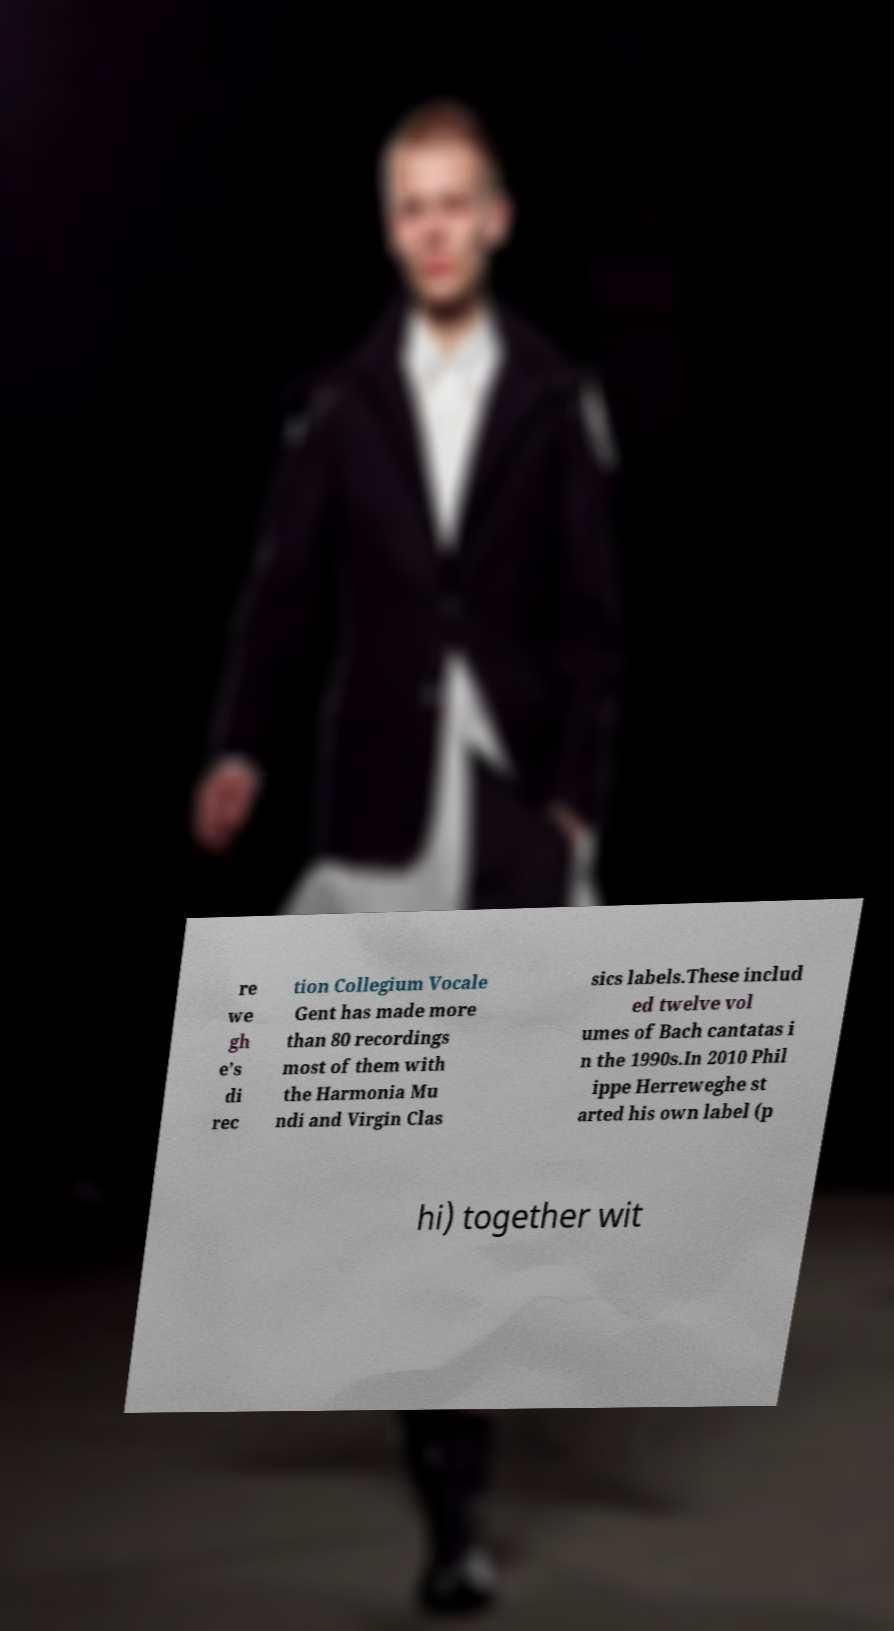There's text embedded in this image that I need extracted. Can you transcribe it verbatim? re we gh e’s di rec tion Collegium Vocale Gent has made more than 80 recordings most of them with the Harmonia Mu ndi and Virgin Clas sics labels.These includ ed twelve vol umes of Bach cantatas i n the 1990s.In 2010 Phil ippe Herreweghe st arted his own label (p hi) together wit 